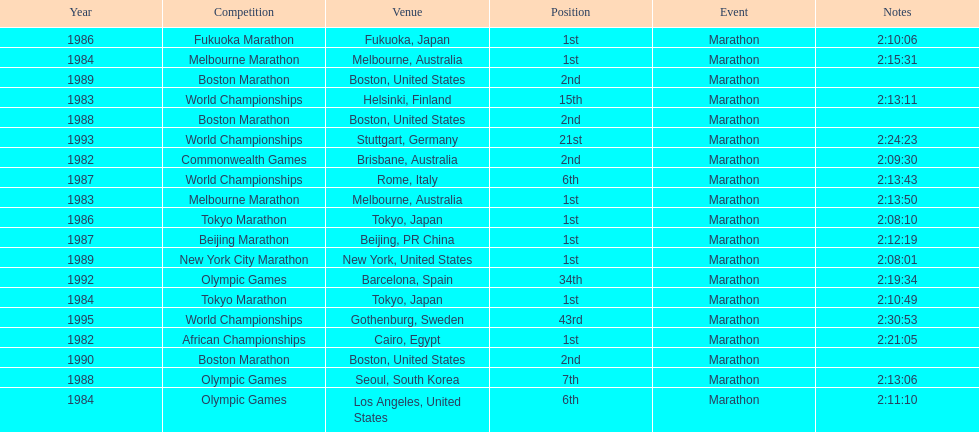Would you be able to parse every entry in this table? {'header': ['Year', 'Competition', 'Venue', 'Position', 'Event', 'Notes'], 'rows': [['1986', 'Fukuoka Marathon', 'Fukuoka, Japan', '1st', 'Marathon', '2:10:06'], ['1984', 'Melbourne Marathon', 'Melbourne, Australia', '1st', 'Marathon', '2:15:31'], ['1989', 'Boston Marathon', 'Boston, United States', '2nd', 'Marathon', ''], ['1983', 'World Championships', 'Helsinki, Finland', '15th', 'Marathon', '2:13:11'], ['1988', 'Boston Marathon', 'Boston, United States', '2nd', 'Marathon', ''], ['1993', 'World Championships', 'Stuttgart, Germany', '21st', 'Marathon', '2:24:23'], ['1982', 'Commonwealth Games', 'Brisbane, Australia', '2nd', 'Marathon', '2:09:30'], ['1987', 'World Championships', 'Rome, Italy', '6th', 'Marathon', '2:13:43'], ['1983', 'Melbourne Marathon', 'Melbourne, Australia', '1st', 'Marathon', '2:13:50'], ['1986', 'Tokyo Marathon', 'Tokyo, Japan', '1st', 'Marathon', '2:08:10'], ['1987', 'Beijing Marathon', 'Beijing, PR China', '1st', 'Marathon', '2:12:19'], ['1989', 'New York City Marathon', 'New York, United States', '1st', 'Marathon', '2:08:01'], ['1992', 'Olympic Games', 'Barcelona, Spain', '34th', 'Marathon', '2:19:34'], ['1984', 'Tokyo Marathon', 'Tokyo, Japan', '1st', 'Marathon', '2:10:49'], ['1995', 'World Championships', 'Gothenburg, Sweden', '43rd', 'Marathon', '2:30:53'], ['1982', 'African Championships', 'Cairo, Egypt', '1st', 'Marathon', '2:21:05'], ['1990', 'Boston Marathon', 'Boston, United States', '2nd', 'Marathon', ''], ['1988', 'Olympic Games', 'Seoul, South Korea', '7th', 'Marathon', '2:13:06'], ['1984', 'Olympic Games', 'Los Angeles, United States', '6th', 'Marathon', '2:11:10']]} What was the first marathon juma ikangaa won? 1982 African Championships. 